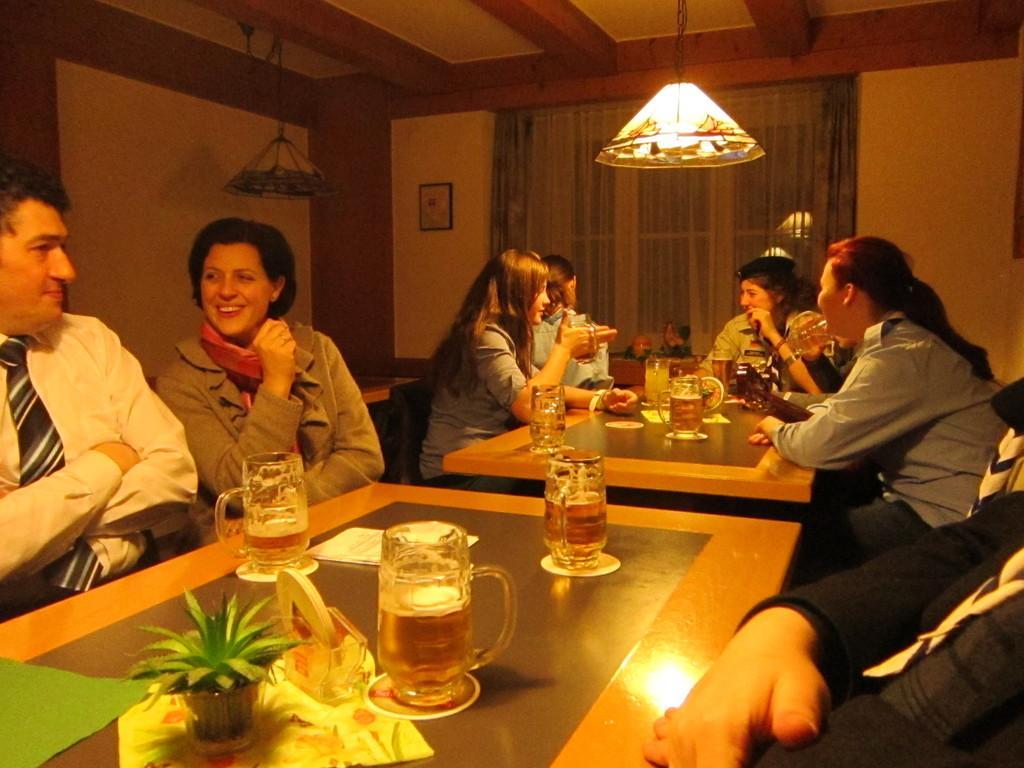How would you summarize this image in a sentence or two? In this image i can see a group of people sitting there are some glasses,a pot on the table, at the back ground there is a curtain, a frame on the wall, a light on the top. 